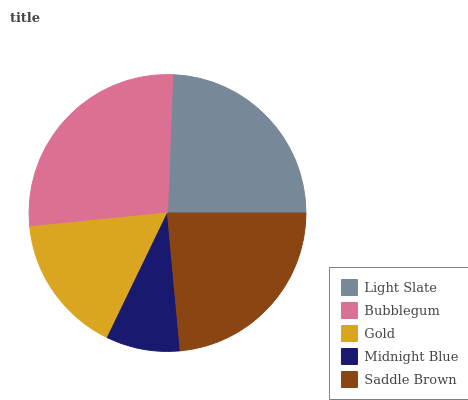Is Midnight Blue the minimum?
Answer yes or no. Yes. Is Bubblegum the maximum?
Answer yes or no. Yes. Is Gold the minimum?
Answer yes or no. No. Is Gold the maximum?
Answer yes or no. No. Is Bubblegum greater than Gold?
Answer yes or no. Yes. Is Gold less than Bubblegum?
Answer yes or no. Yes. Is Gold greater than Bubblegum?
Answer yes or no. No. Is Bubblegum less than Gold?
Answer yes or no. No. Is Saddle Brown the high median?
Answer yes or no. Yes. Is Saddle Brown the low median?
Answer yes or no. Yes. Is Gold the high median?
Answer yes or no. No. Is Midnight Blue the low median?
Answer yes or no. No. 